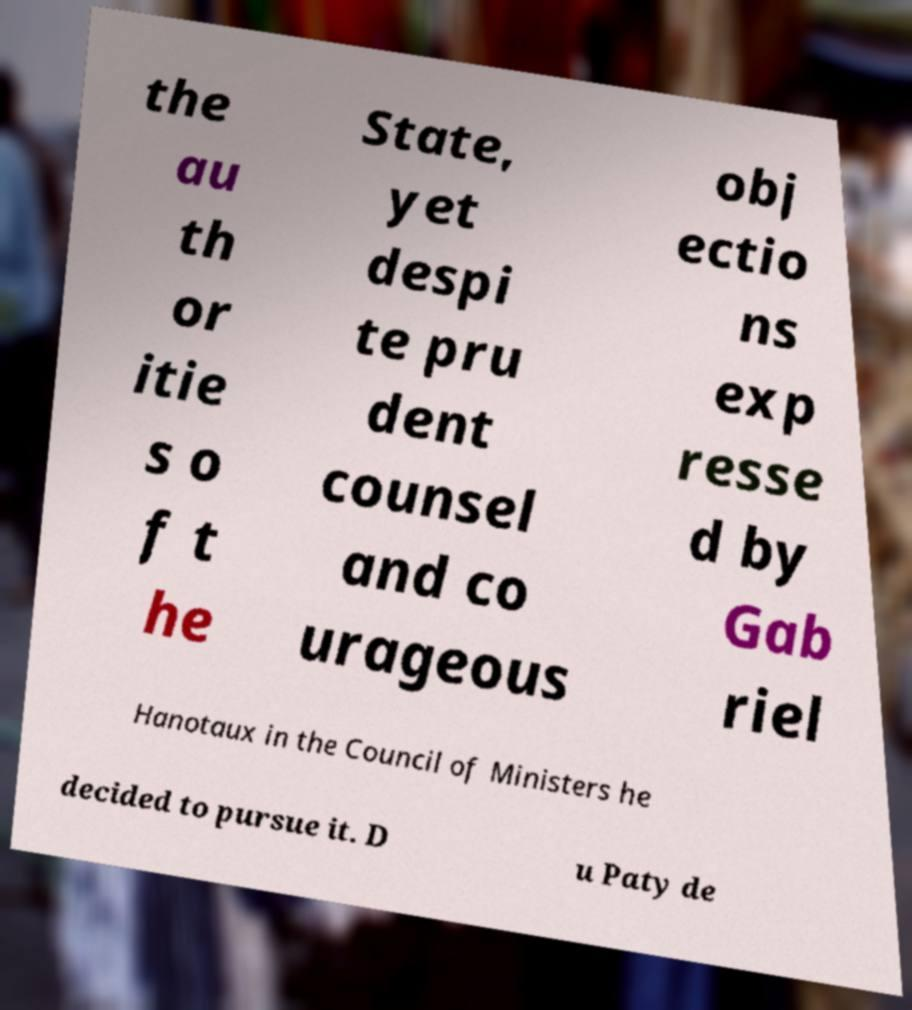What messages or text are displayed in this image? I need them in a readable, typed format. the au th or itie s o f t he State, yet despi te pru dent counsel and co urageous obj ectio ns exp resse d by Gab riel Hanotaux in the Council of Ministers he decided to pursue it. D u Paty de 